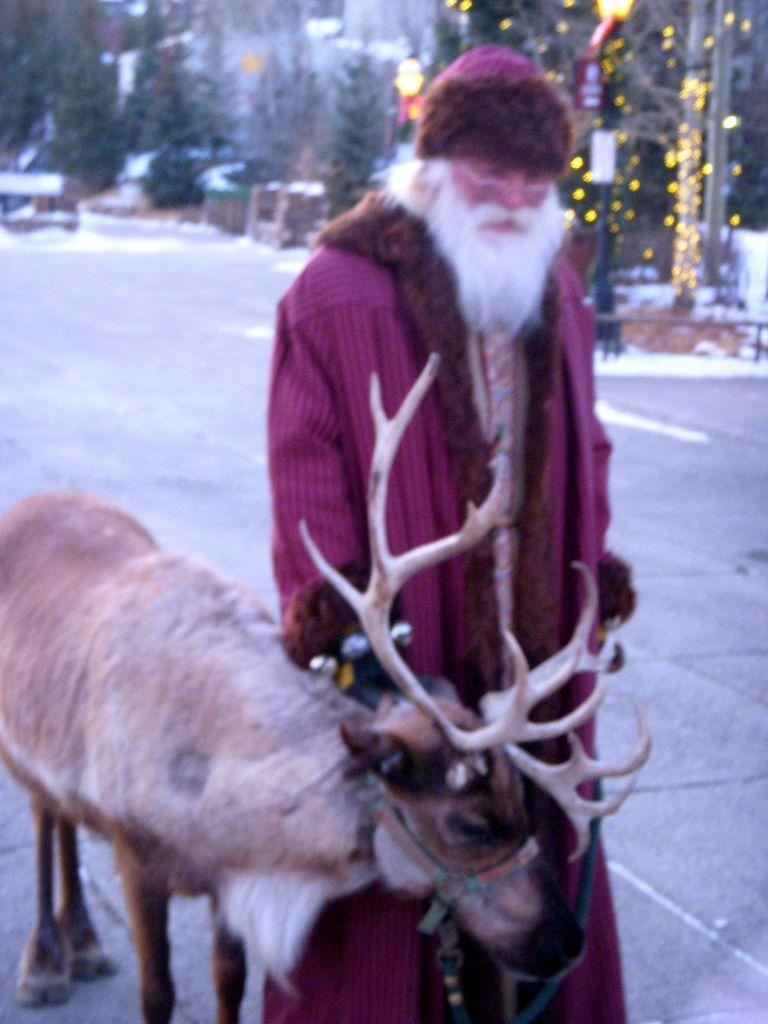What is the main subject of the image? There is a person in the image. How is the person dressed? The person is wearing a fancy dress. What animal can be seen in the image? There is a reindeer in the image. What type of weather is depicted in the image? There is snow in the image. What type of natural environment is visible in the image? There are trees in the image. What additional decorations are present in the image? There are lights and a pole in the image. What type of potato is being served in the lunchroom in the image? There is no lunchroom or potato present in the image. What type of wilderness can be seen in the background of the image? There is no wilderness visible in the image; it features a person, a reindeer, trees, and other decorations. 